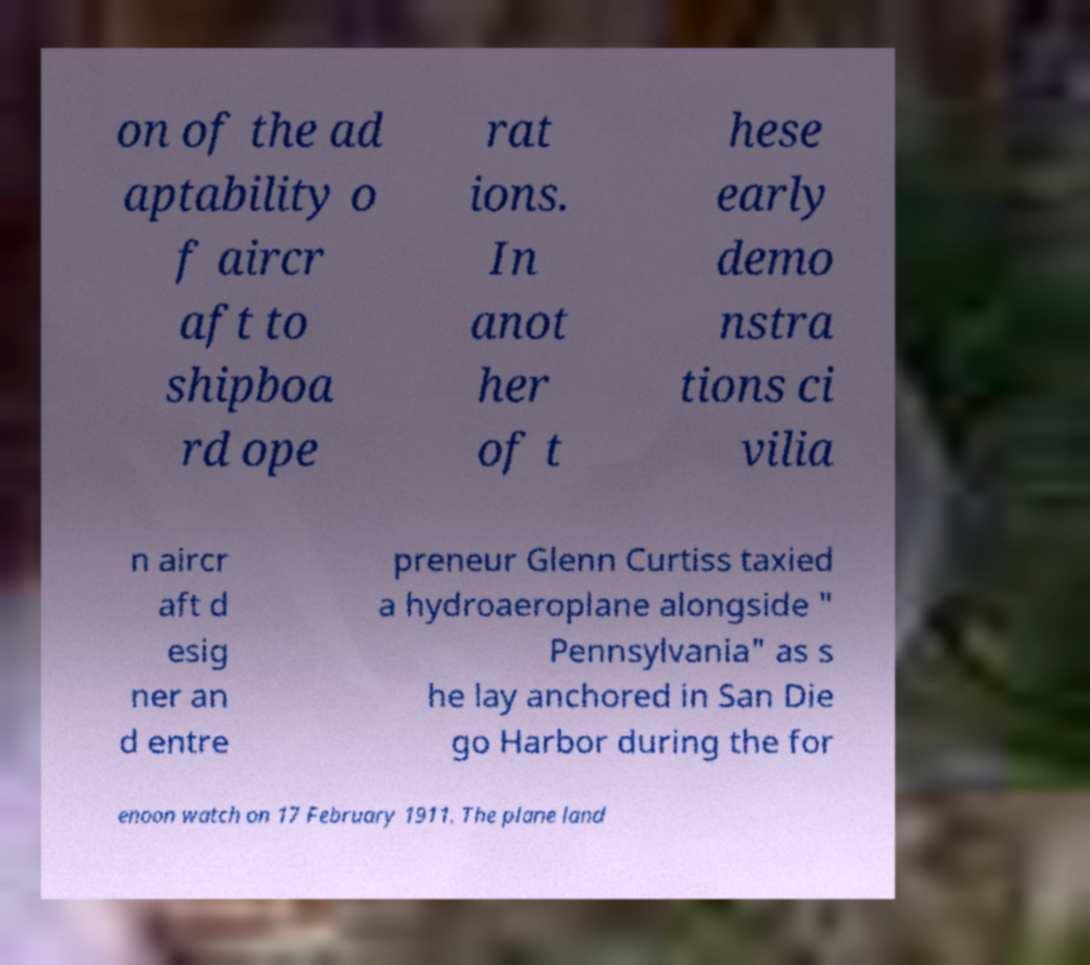Can you read and provide the text displayed in the image?This photo seems to have some interesting text. Can you extract and type it out for me? on of the ad aptability o f aircr aft to shipboa rd ope rat ions. In anot her of t hese early demo nstra tions ci vilia n aircr aft d esig ner an d entre preneur Glenn Curtiss taxied a hydroaeroplane alongside " Pennsylvania" as s he lay anchored in San Die go Harbor during the for enoon watch on 17 February 1911. The plane land 